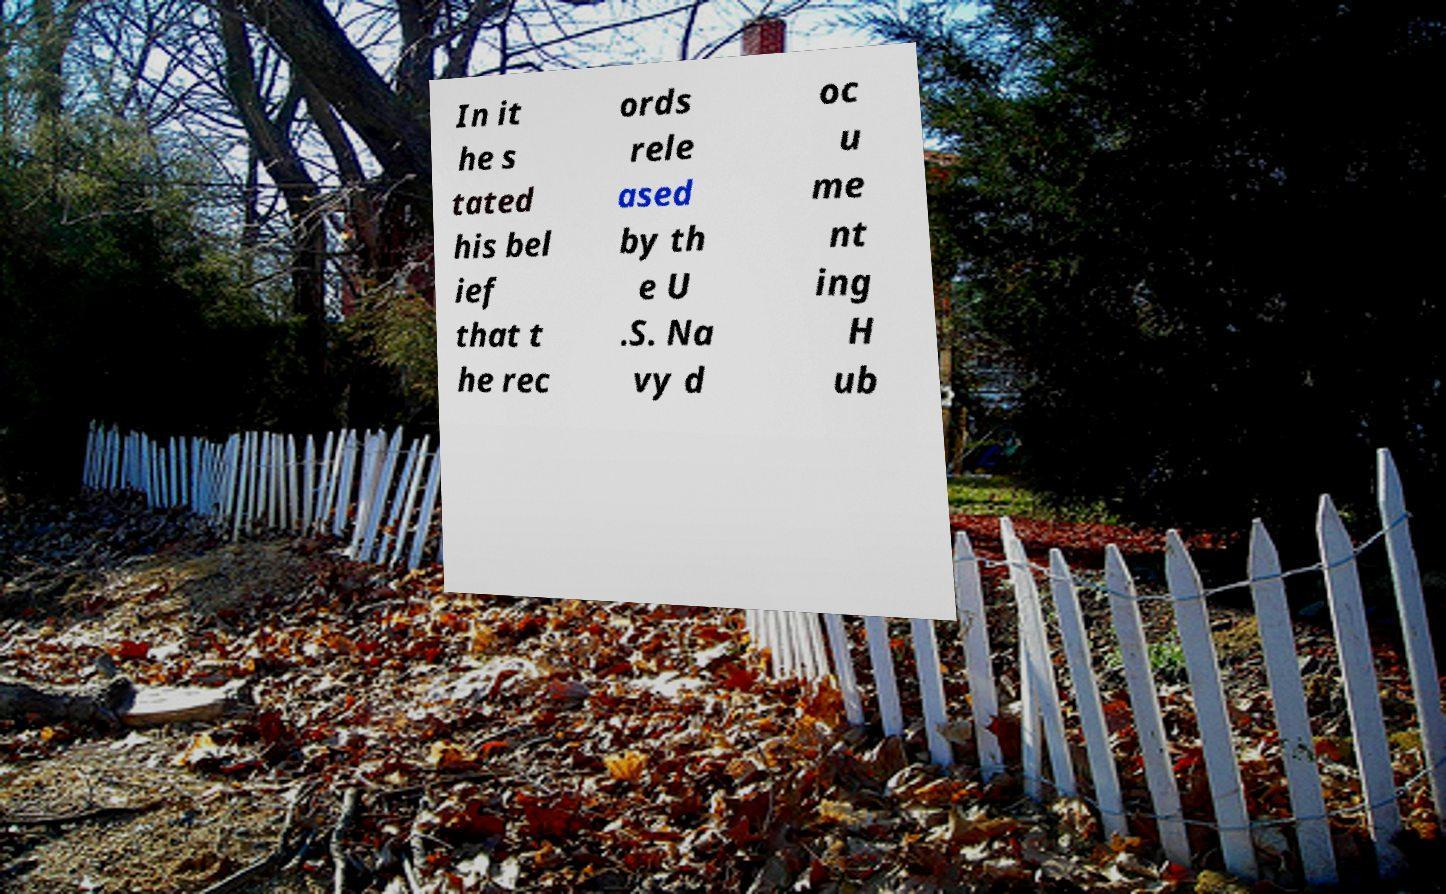I need the written content from this picture converted into text. Can you do that? In it he s tated his bel ief that t he rec ords rele ased by th e U .S. Na vy d oc u me nt ing H ub 